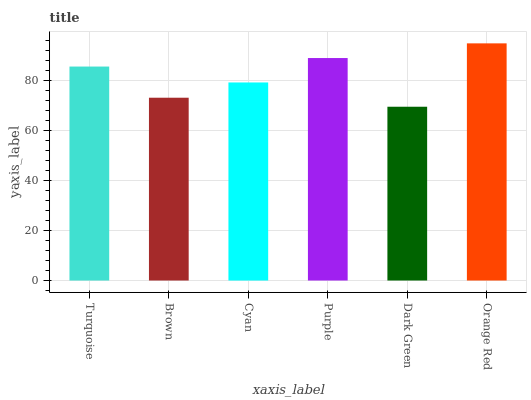Is Dark Green the minimum?
Answer yes or no. Yes. Is Orange Red the maximum?
Answer yes or no. Yes. Is Brown the minimum?
Answer yes or no. No. Is Brown the maximum?
Answer yes or no. No. Is Turquoise greater than Brown?
Answer yes or no. Yes. Is Brown less than Turquoise?
Answer yes or no. Yes. Is Brown greater than Turquoise?
Answer yes or no. No. Is Turquoise less than Brown?
Answer yes or no. No. Is Turquoise the high median?
Answer yes or no. Yes. Is Cyan the low median?
Answer yes or no. Yes. Is Purple the high median?
Answer yes or no. No. Is Orange Red the low median?
Answer yes or no. No. 